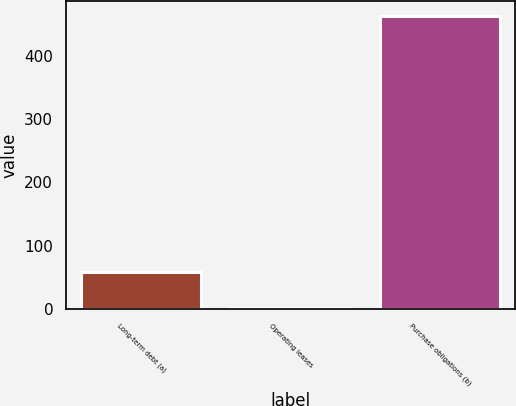<chart> <loc_0><loc_0><loc_500><loc_500><bar_chart><fcel>Long-term debt (a)<fcel>Operating leases<fcel>Purchase obligations (b)<nl><fcel>59<fcel>1<fcel>463<nl></chart> 